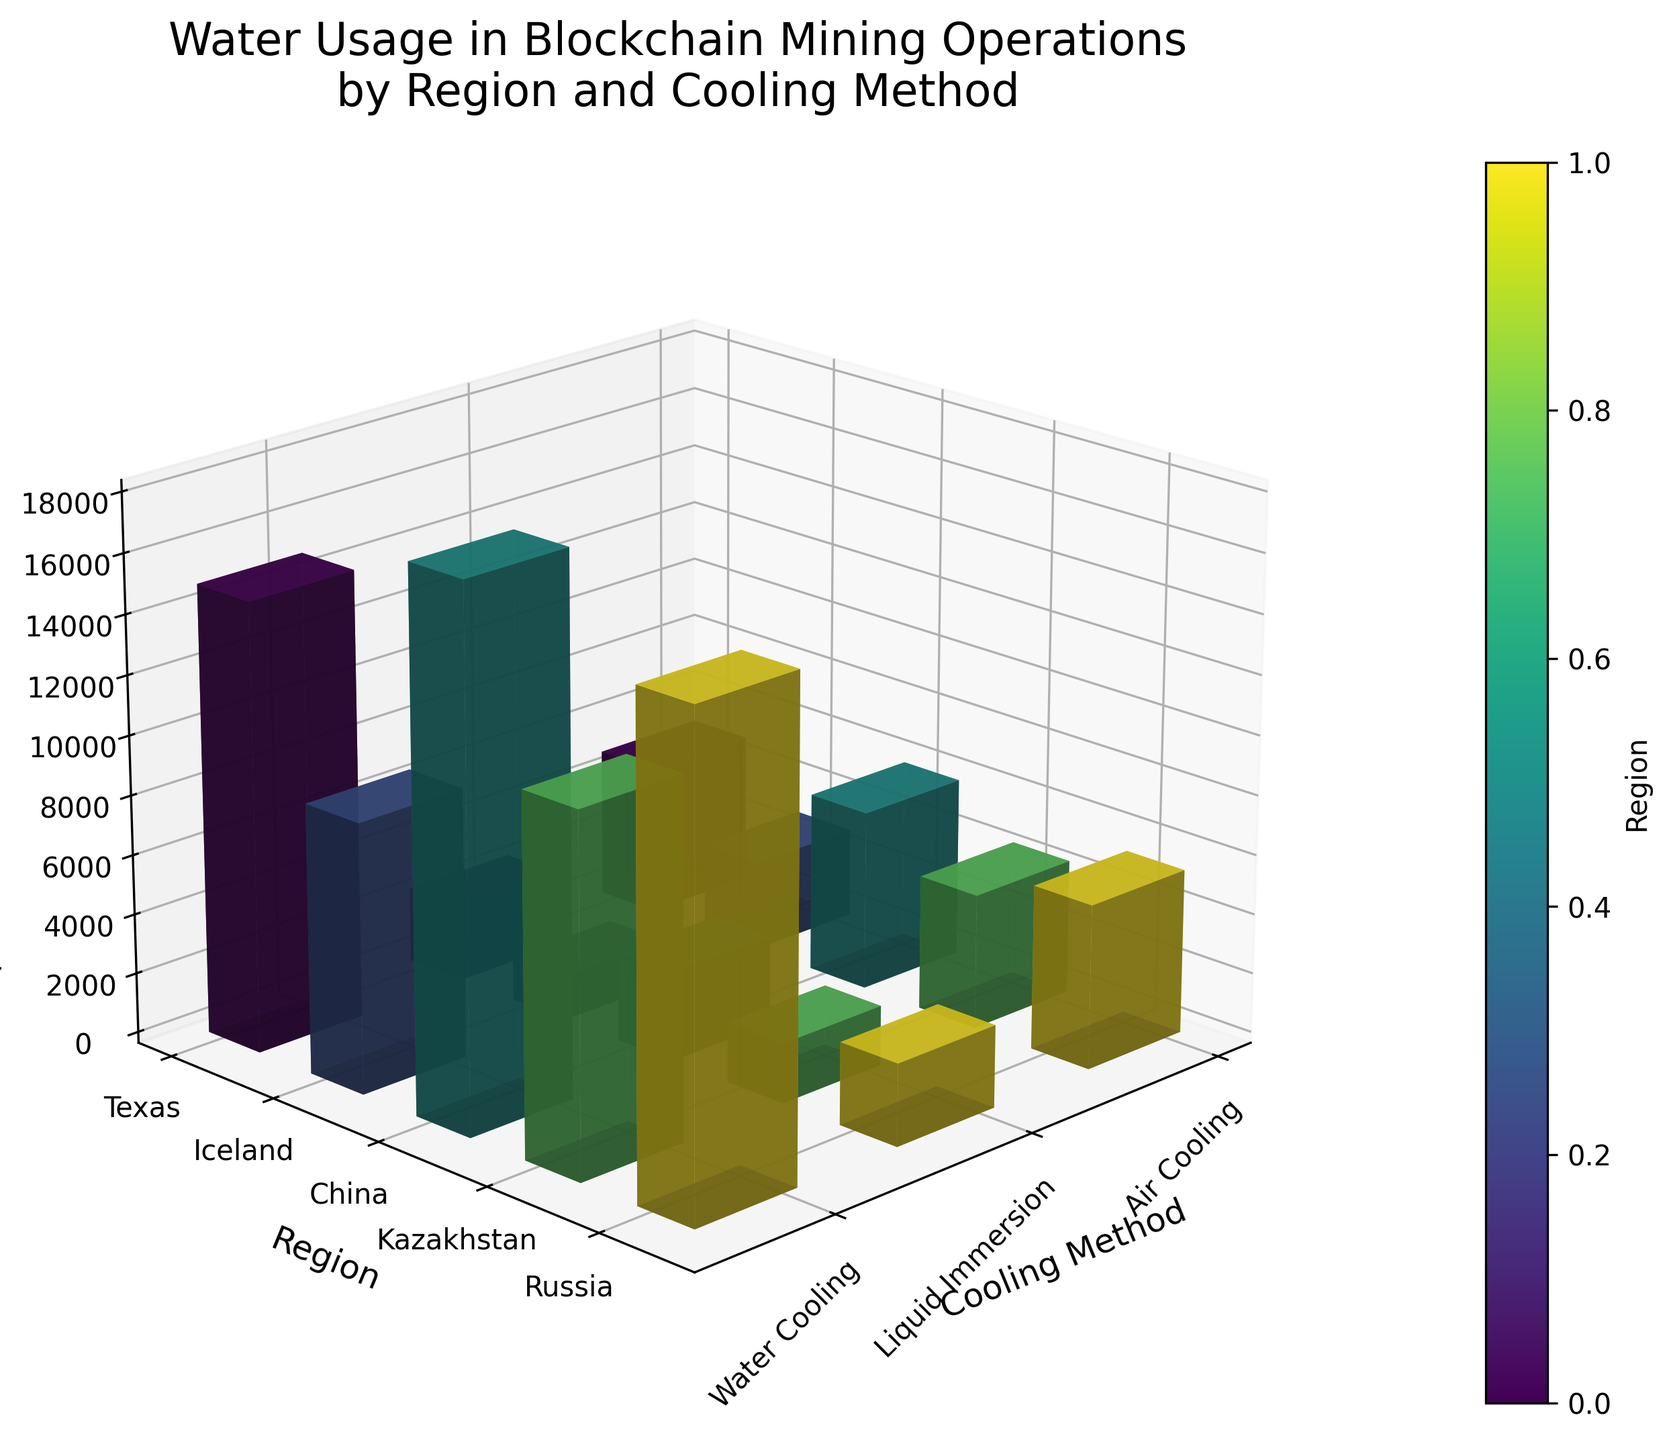What is the title of the figure? The title is generally located at the top of the figure. By checking that area, you can read the given title.
Answer: Water Usage in Blockchain Mining Operations by Region and Cooling Method Which region uses the most water with water cooling? Look at the heights of the bars corresponding to "Water Cooling" for each region and identify the tallest one.
Answer: China Which cooling method generally uses the least water? Observe the heights of the bars for each cooling method across all regions and compare. The shortest bars on average indicate the least water usage.
Answer: Liquid Immersion How many cooling methods are compared in the figure? By counting the distinct labels along the x-axis, you can determine the number of cooling methods compared in the plot.
Answer: 3 Which region has the highest water usage for air cooling? Identify the bars labeled "Air Cooling" and compare their heights across the regions. The region with the tallest bar has the highest usage.
Answer: China Compare the water usage between Texas and Iceland for liquid immersion cooling. Which region uses more water, and by how much? Find the bars for "Liquid Immersion" for both Texas and Iceland, and note their heights. Subtract the smaller value from the larger to find the difference.
Answer: Texas uses 1000 liters/day more than Iceland What's the difference in water usage between air cooling and liquid immersion cooling in Kazakhstan? Identify the bars for "Air Cooling" and "Liquid Immersion" in Kazakhstan, then subtract the height of "Liquid Immersion" from "Air Cooling."
Answer: 2500 liters/day What is the median water usage for all regions using air cooling? Extract the water usage values for "Air Cooling" across all regions, which are 5000, 3000, 6000, 4500, 5500. Sort these values and find the middle one to get the median.
Answer: 5000 liters/day Which cooling method shows the largest variation in water usage between different regions? Compare the range of water usage values (difference between highest and lowest) for each cooling method across regions to identify the one with the largest variability.
Answer: Water Cooling How does the water usage for air cooling change between Texas and Russia? Compare the heights of the "Air Cooling" bars for Texas and Russia, then note if it increases or decreases when moving from Texas to Russia.
Answer: Increases from Texas to Russia 